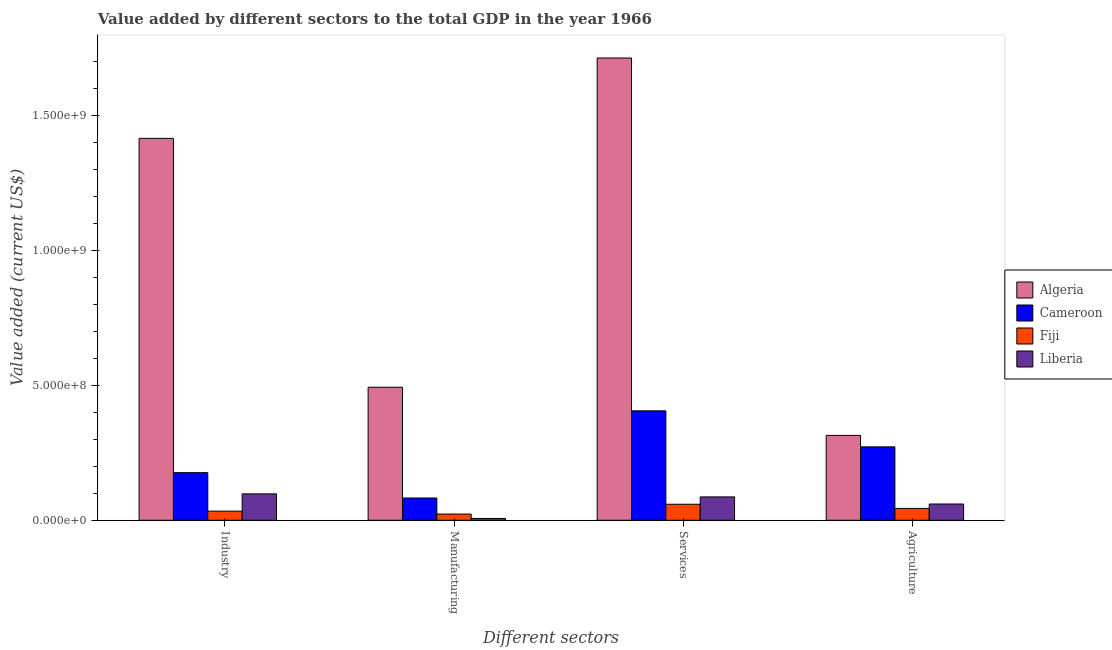How many different coloured bars are there?
Provide a succinct answer. 4. Are the number of bars on each tick of the X-axis equal?
Keep it short and to the point. Yes. How many bars are there on the 2nd tick from the left?
Your answer should be compact. 4. What is the label of the 3rd group of bars from the left?
Your answer should be very brief. Services. What is the value added by manufacturing sector in Fiji?
Give a very brief answer. 2.30e+07. Across all countries, what is the maximum value added by manufacturing sector?
Make the answer very short. 4.93e+08. Across all countries, what is the minimum value added by services sector?
Ensure brevity in your answer.  5.93e+07. In which country was the value added by agricultural sector maximum?
Offer a very short reply. Algeria. In which country was the value added by manufacturing sector minimum?
Ensure brevity in your answer.  Liberia. What is the total value added by manufacturing sector in the graph?
Your answer should be compact. 6.05e+08. What is the difference between the value added by industrial sector in Algeria and that in Fiji?
Make the answer very short. 1.38e+09. What is the difference between the value added by services sector in Fiji and the value added by industrial sector in Liberia?
Your answer should be very brief. -3.85e+07. What is the average value added by industrial sector per country?
Give a very brief answer. 4.30e+08. What is the difference between the value added by manufacturing sector and value added by agricultural sector in Fiji?
Give a very brief answer. -2.08e+07. In how many countries, is the value added by manufacturing sector greater than 400000000 US$?
Offer a very short reply. 1. What is the ratio of the value added by agricultural sector in Liberia to that in Fiji?
Your answer should be compact. 1.37. Is the value added by industrial sector in Algeria less than that in Fiji?
Ensure brevity in your answer.  No. What is the difference between the highest and the second highest value added by services sector?
Your answer should be compact. 1.31e+09. What is the difference between the highest and the lowest value added by manufacturing sector?
Provide a succinct answer. 4.86e+08. What does the 3rd bar from the left in Manufacturing represents?
Provide a succinct answer. Fiji. What does the 1st bar from the right in Industry represents?
Provide a succinct answer. Liberia. How many countries are there in the graph?
Provide a short and direct response. 4. What is the difference between two consecutive major ticks on the Y-axis?
Keep it short and to the point. 5.00e+08. Are the values on the major ticks of Y-axis written in scientific E-notation?
Ensure brevity in your answer.  Yes. Where does the legend appear in the graph?
Offer a very short reply. Center right. How many legend labels are there?
Offer a very short reply. 4. How are the legend labels stacked?
Provide a succinct answer. Vertical. What is the title of the graph?
Keep it short and to the point. Value added by different sectors to the total GDP in the year 1966. What is the label or title of the X-axis?
Offer a very short reply. Different sectors. What is the label or title of the Y-axis?
Make the answer very short. Value added (current US$). What is the Value added (current US$) of Algeria in Industry?
Your answer should be very brief. 1.41e+09. What is the Value added (current US$) of Cameroon in Industry?
Keep it short and to the point. 1.76e+08. What is the Value added (current US$) in Fiji in Industry?
Keep it short and to the point. 3.38e+07. What is the Value added (current US$) in Liberia in Industry?
Your response must be concise. 9.78e+07. What is the Value added (current US$) in Algeria in Manufacturing?
Ensure brevity in your answer.  4.93e+08. What is the Value added (current US$) in Cameroon in Manufacturing?
Offer a very short reply. 8.24e+07. What is the Value added (current US$) of Fiji in Manufacturing?
Your answer should be compact. 2.30e+07. What is the Value added (current US$) of Liberia in Manufacturing?
Your answer should be very brief. 6.66e+06. What is the Value added (current US$) in Algeria in Services?
Offer a terse response. 1.71e+09. What is the Value added (current US$) of Cameroon in Services?
Your response must be concise. 4.05e+08. What is the Value added (current US$) of Fiji in Services?
Give a very brief answer. 5.93e+07. What is the Value added (current US$) of Liberia in Services?
Provide a short and direct response. 8.65e+07. What is the Value added (current US$) of Algeria in Agriculture?
Give a very brief answer. 3.14e+08. What is the Value added (current US$) of Cameroon in Agriculture?
Ensure brevity in your answer.  2.72e+08. What is the Value added (current US$) of Fiji in Agriculture?
Keep it short and to the point. 4.38e+07. What is the Value added (current US$) in Liberia in Agriculture?
Provide a short and direct response. 6.02e+07. Across all Different sectors, what is the maximum Value added (current US$) of Algeria?
Offer a terse response. 1.71e+09. Across all Different sectors, what is the maximum Value added (current US$) in Cameroon?
Your answer should be very brief. 4.05e+08. Across all Different sectors, what is the maximum Value added (current US$) of Fiji?
Give a very brief answer. 5.93e+07. Across all Different sectors, what is the maximum Value added (current US$) of Liberia?
Ensure brevity in your answer.  9.78e+07. Across all Different sectors, what is the minimum Value added (current US$) in Algeria?
Your response must be concise. 3.14e+08. Across all Different sectors, what is the minimum Value added (current US$) in Cameroon?
Provide a short and direct response. 8.24e+07. Across all Different sectors, what is the minimum Value added (current US$) in Fiji?
Offer a very short reply. 2.30e+07. Across all Different sectors, what is the minimum Value added (current US$) in Liberia?
Your answer should be very brief. 6.66e+06. What is the total Value added (current US$) of Algeria in the graph?
Keep it short and to the point. 3.93e+09. What is the total Value added (current US$) in Cameroon in the graph?
Make the answer very short. 9.36e+08. What is the total Value added (current US$) of Fiji in the graph?
Give a very brief answer. 1.60e+08. What is the total Value added (current US$) in Liberia in the graph?
Keep it short and to the point. 2.51e+08. What is the difference between the Value added (current US$) in Algeria in Industry and that in Manufacturing?
Your answer should be compact. 9.21e+08. What is the difference between the Value added (current US$) in Cameroon in Industry and that in Manufacturing?
Your response must be concise. 9.39e+07. What is the difference between the Value added (current US$) in Fiji in Industry and that in Manufacturing?
Ensure brevity in your answer.  1.08e+07. What is the difference between the Value added (current US$) of Liberia in Industry and that in Manufacturing?
Your response must be concise. 9.11e+07. What is the difference between the Value added (current US$) in Algeria in Industry and that in Services?
Offer a very short reply. -2.98e+08. What is the difference between the Value added (current US$) in Cameroon in Industry and that in Services?
Offer a very short reply. -2.29e+08. What is the difference between the Value added (current US$) of Fiji in Industry and that in Services?
Provide a succinct answer. -2.54e+07. What is the difference between the Value added (current US$) in Liberia in Industry and that in Services?
Your answer should be very brief. 1.13e+07. What is the difference between the Value added (current US$) in Algeria in Industry and that in Agriculture?
Provide a short and direct response. 1.10e+09. What is the difference between the Value added (current US$) in Cameroon in Industry and that in Agriculture?
Your response must be concise. -9.55e+07. What is the difference between the Value added (current US$) in Fiji in Industry and that in Agriculture?
Offer a very short reply. -9.94e+06. What is the difference between the Value added (current US$) in Liberia in Industry and that in Agriculture?
Provide a succinct answer. 3.76e+07. What is the difference between the Value added (current US$) of Algeria in Manufacturing and that in Services?
Make the answer very short. -1.22e+09. What is the difference between the Value added (current US$) of Cameroon in Manufacturing and that in Services?
Ensure brevity in your answer.  -3.23e+08. What is the difference between the Value added (current US$) in Fiji in Manufacturing and that in Services?
Offer a terse response. -3.62e+07. What is the difference between the Value added (current US$) of Liberia in Manufacturing and that in Services?
Ensure brevity in your answer.  -7.98e+07. What is the difference between the Value added (current US$) of Algeria in Manufacturing and that in Agriculture?
Ensure brevity in your answer.  1.78e+08. What is the difference between the Value added (current US$) in Cameroon in Manufacturing and that in Agriculture?
Provide a succinct answer. -1.89e+08. What is the difference between the Value added (current US$) of Fiji in Manufacturing and that in Agriculture?
Make the answer very short. -2.08e+07. What is the difference between the Value added (current US$) of Liberia in Manufacturing and that in Agriculture?
Offer a terse response. -5.35e+07. What is the difference between the Value added (current US$) of Algeria in Services and that in Agriculture?
Your answer should be compact. 1.40e+09. What is the difference between the Value added (current US$) in Cameroon in Services and that in Agriculture?
Offer a very short reply. 1.33e+08. What is the difference between the Value added (current US$) in Fiji in Services and that in Agriculture?
Give a very brief answer. 1.55e+07. What is the difference between the Value added (current US$) of Liberia in Services and that in Agriculture?
Provide a short and direct response. 2.63e+07. What is the difference between the Value added (current US$) of Algeria in Industry and the Value added (current US$) of Cameroon in Manufacturing?
Your response must be concise. 1.33e+09. What is the difference between the Value added (current US$) of Algeria in Industry and the Value added (current US$) of Fiji in Manufacturing?
Your response must be concise. 1.39e+09. What is the difference between the Value added (current US$) in Algeria in Industry and the Value added (current US$) in Liberia in Manufacturing?
Your response must be concise. 1.41e+09. What is the difference between the Value added (current US$) of Cameroon in Industry and the Value added (current US$) of Fiji in Manufacturing?
Your response must be concise. 1.53e+08. What is the difference between the Value added (current US$) of Cameroon in Industry and the Value added (current US$) of Liberia in Manufacturing?
Make the answer very short. 1.70e+08. What is the difference between the Value added (current US$) of Fiji in Industry and the Value added (current US$) of Liberia in Manufacturing?
Your answer should be very brief. 2.72e+07. What is the difference between the Value added (current US$) in Algeria in Industry and the Value added (current US$) in Cameroon in Services?
Your answer should be compact. 1.01e+09. What is the difference between the Value added (current US$) of Algeria in Industry and the Value added (current US$) of Fiji in Services?
Your answer should be compact. 1.35e+09. What is the difference between the Value added (current US$) in Algeria in Industry and the Value added (current US$) in Liberia in Services?
Offer a very short reply. 1.33e+09. What is the difference between the Value added (current US$) in Cameroon in Industry and the Value added (current US$) in Fiji in Services?
Ensure brevity in your answer.  1.17e+08. What is the difference between the Value added (current US$) in Cameroon in Industry and the Value added (current US$) in Liberia in Services?
Ensure brevity in your answer.  8.98e+07. What is the difference between the Value added (current US$) of Fiji in Industry and the Value added (current US$) of Liberia in Services?
Your answer should be very brief. -5.27e+07. What is the difference between the Value added (current US$) in Algeria in Industry and the Value added (current US$) in Cameroon in Agriculture?
Your answer should be compact. 1.14e+09. What is the difference between the Value added (current US$) in Algeria in Industry and the Value added (current US$) in Fiji in Agriculture?
Keep it short and to the point. 1.37e+09. What is the difference between the Value added (current US$) of Algeria in Industry and the Value added (current US$) of Liberia in Agriculture?
Offer a terse response. 1.35e+09. What is the difference between the Value added (current US$) in Cameroon in Industry and the Value added (current US$) in Fiji in Agriculture?
Your response must be concise. 1.33e+08. What is the difference between the Value added (current US$) of Cameroon in Industry and the Value added (current US$) of Liberia in Agriculture?
Your response must be concise. 1.16e+08. What is the difference between the Value added (current US$) of Fiji in Industry and the Value added (current US$) of Liberia in Agriculture?
Provide a short and direct response. -2.64e+07. What is the difference between the Value added (current US$) of Algeria in Manufacturing and the Value added (current US$) of Cameroon in Services?
Offer a very short reply. 8.74e+07. What is the difference between the Value added (current US$) in Algeria in Manufacturing and the Value added (current US$) in Fiji in Services?
Give a very brief answer. 4.33e+08. What is the difference between the Value added (current US$) in Algeria in Manufacturing and the Value added (current US$) in Liberia in Services?
Ensure brevity in your answer.  4.06e+08. What is the difference between the Value added (current US$) of Cameroon in Manufacturing and the Value added (current US$) of Fiji in Services?
Your response must be concise. 2.32e+07. What is the difference between the Value added (current US$) of Cameroon in Manufacturing and the Value added (current US$) of Liberia in Services?
Keep it short and to the point. -4.07e+06. What is the difference between the Value added (current US$) in Fiji in Manufacturing and the Value added (current US$) in Liberia in Services?
Your answer should be compact. -6.35e+07. What is the difference between the Value added (current US$) of Algeria in Manufacturing and the Value added (current US$) of Cameroon in Agriculture?
Provide a short and direct response. 2.21e+08. What is the difference between the Value added (current US$) in Algeria in Manufacturing and the Value added (current US$) in Fiji in Agriculture?
Your response must be concise. 4.49e+08. What is the difference between the Value added (current US$) of Algeria in Manufacturing and the Value added (current US$) of Liberia in Agriculture?
Offer a very short reply. 4.32e+08. What is the difference between the Value added (current US$) in Cameroon in Manufacturing and the Value added (current US$) in Fiji in Agriculture?
Offer a terse response. 3.86e+07. What is the difference between the Value added (current US$) of Cameroon in Manufacturing and the Value added (current US$) of Liberia in Agriculture?
Your answer should be very brief. 2.22e+07. What is the difference between the Value added (current US$) of Fiji in Manufacturing and the Value added (current US$) of Liberia in Agriculture?
Make the answer very short. -3.72e+07. What is the difference between the Value added (current US$) in Algeria in Services and the Value added (current US$) in Cameroon in Agriculture?
Provide a short and direct response. 1.44e+09. What is the difference between the Value added (current US$) in Algeria in Services and the Value added (current US$) in Fiji in Agriculture?
Your answer should be very brief. 1.67e+09. What is the difference between the Value added (current US$) in Algeria in Services and the Value added (current US$) in Liberia in Agriculture?
Keep it short and to the point. 1.65e+09. What is the difference between the Value added (current US$) of Cameroon in Services and the Value added (current US$) of Fiji in Agriculture?
Your answer should be very brief. 3.61e+08. What is the difference between the Value added (current US$) in Cameroon in Services and the Value added (current US$) in Liberia in Agriculture?
Your response must be concise. 3.45e+08. What is the difference between the Value added (current US$) of Fiji in Services and the Value added (current US$) of Liberia in Agriculture?
Keep it short and to the point. -9.37e+05. What is the average Value added (current US$) in Algeria per Different sectors?
Ensure brevity in your answer.  9.83e+08. What is the average Value added (current US$) of Cameroon per Different sectors?
Make the answer very short. 2.34e+08. What is the average Value added (current US$) of Fiji per Different sectors?
Provide a short and direct response. 4.00e+07. What is the average Value added (current US$) in Liberia per Different sectors?
Offer a very short reply. 6.28e+07. What is the difference between the Value added (current US$) in Algeria and Value added (current US$) in Cameroon in Industry?
Ensure brevity in your answer.  1.24e+09. What is the difference between the Value added (current US$) in Algeria and Value added (current US$) in Fiji in Industry?
Give a very brief answer. 1.38e+09. What is the difference between the Value added (current US$) of Algeria and Value added (current US$) of Liberia in Industry?
Provide a short and direct response. 1.32e+09. What is the difference between the Value added (current US$) of Cameroon and Value added (current US$) of Fiji in Industry?
Offer a very short reply. 1.42e+08. What is the difference between the Value added (current US$) of Cameroon and Value added (current US$) of Liberia in Industry?
Your response must be concise. 7.85e+07. What is the difference between the Value added (current US$) of Fiji and Value added (current US$) of Liberia in Industry?
Offer a terse response. -6.39e+07. What is the difference between the Value added (current US$) in Algeria and Value added (current US$) in Cameroon in Manufacturing?
Your answer should be compact. 4.10e+08. What is the difference between the Value added (current US$) in Algeria and Value added (current US$) in Fiji in Manufacturing?
Provide a succinct answer. 4.70e+08. What is the difference between the Value added (current US$) of Algeria and Value added (current US$) of Liberia in Manufacturing?
Give a very brief answer. 4.86e+08. What is the difference between the Value added (current US$) of Cameroon and Value added (current US$) of Fiji in Manufacturing?
Keep it short and to the point. 5.94e+07. What is the difference between the Value added (current US$) in Cameroon and Value added (current US$) in Liberia in Manufacturing?
Offer a terse response. 7.58e+07. What is the difference between the Value added (current US$) of Fiji and Value added (current US$) of Liberia in Manufacturing?
Keep it short and to the point. 1.64e+07. What is the difference between the Value added (current US$) in Algeria and Value added (current US$) in Cameroon in Services?
Your answer should be very brief. 1.31e+09. What is the difference between the Value added (current US$) of Algeria and Value added (current US$) of Fiji in Services?
Your answer should be very brief. 1.65e+09. What is the difference between the Value added (current US$) in Algeria and Value added (current US$) in Liberia in Services?
Your answer should be compact. 1.63e+09. What is the difference between the Value added (current US$) in Cameroon and Value added (current US$) in Fiji in Services?
Provide a short and direct response. 3.46e+08. What is the difference between the Value added (current US$) in Cameroon and Value added (current US$) in Liberia in Services?
Your answer should be compact. 3.19e+08. What is the difference between the Value added (current US$) of Fiji and Value added (current US$) of Liberia in Services?
Ensure brevity in your answer.  -2.72e+07. What is the difference between the Value added (current US$) of Algeria and Value added (current US$) of Cameroon in Agriculture?
Make the answer very short. 4.26e+07. What is the difference between the Value added (current US$) of Algeria and Value added (current US$) of Fiji in Agriculture?
Offer a terse response. 2.71e+08. What is the difference between the Value added (current US$) of Algeria and Value added (current US$) of Liberia in Agriculture?
Your answer should be compact. 2.54e+08. What is the difference between the Value added (current US$) in Cameroon and Value added (current US$) in Fiji in Agriculture?
Offer a very short reply. 2.28e+08. What is the difference between the Value added (current US$) of Cameroon and Value added (current US$) of Liberia in Agriculture?
Your response must be concise. 2.12e+08. What is the difference between the Value added (current US$) in Fiji and Value added (current US$) in Liberia in Agriculture?
Give a very brief answer. -1.64e+07. What is the ratio of the Value added (current US$) of Algeria in Industry to that in Manufacturing?
Offer a very short reply. 2.87. What is the ratio of the Value added (current US$) of Cameroon in Industry to that in Manufacturing?
Keep it short and to the point. 2.14. What is the ratio of the Value added (current US$) in Fiji in Industry to that in Manufacturing?
Your response must be concise. 1.47. What is the ratio of the Value added (current US$) of Liberia in Industry to that in Manufacturing?
Your answer should be compact. 14.68. What is the ratio of the Value added (current US$) of Algeria in Industry to that in Services?
Offer a very short reply. 0.83. What is the ratio of the Value added (current US$) in Cameroon in Industry to that in Services?
Offer a very short reply. 0.43. What is the ratio of the Value added (current US$) of Fiji in Industry to that in Services?
Keep it short and to the point. 0.57. What is the ratio of the Value added (current US$) of Liberia in Industry to that in Services?
Give a very brief answer. 1.13. What is the ratio of the Value added (current US$) in Algeria in Industry to that in Agriculture?
Offer a terse response. 4.5. What is the ratio of the Value added (current US$) in Cameroon in Industry to that in Agriculture?
Your response must be concise. 0.65. What is the ratio of the Value added (current US$) in Fiji in Industry to that in Agriculture?
Offer a very short reply. 0.77. What is the ratio of the Value added (current US$) in Liberia in Industry to that in Agriculture?
Make the answer very short. 1.62. What is the ratio of the Value added (current US$) in Algeria in Manufacturing to that in Services?
Provide a succinct answer. 0.29. What is the ratio of the Value added (current US$) in Cameroon in Manufacturing to that in Services?
Offer a terse response. 0.2. What is the ratio of the Value added (current US$) in Fiji in Manufacturing to that in Services?
Your answer should be very brief. 0.39. What is the ratio of the Value added (current US$) in Liberia in Manufacturing to that in Services?
Your answer should be very brief. 0.08. What is the ratio of the Value added (current US$) of Algeria in Manufacturing to that in Agriculture?
Ensure brevity in your answer.  1.57. What is the ratio of the Value added (current US$) in Cameroon in Manufacturing to that in Agriculture?
Your response must be concise. 0.3. What is the ratio of the Value added (current US$) in Fiji in Manufacturing to that in Agriculture?
Provide a short and direct response. 0.53. What is the ratio of the Value added (current US$) of Liberia in Manufacturing to that in Agriculture?
Provide a short and direct response. 0.11. What is the ratio of the Value added (current US$) of Algeria in Services to that in Agriculture?
Provide a succinct answer. 5.45. What is the ratio of the Value added (current US$) of Cameroon in Services to that in Agriculture?
Keep it short and to the point. 1.49. What is the ratio of the Value added (current US$) in Fiji in Services to that in Agriculture?
Make the answer very short. 1.35. What is the ratio of the Value added (current US$) of Liberia in Services to that in Agriculture?
Your answer should be very brief. 1.44. What is the difference between the highest and the second highest Value added (current US$) in Algeria?
Make the answer very short. 2.98e+08. What is the difference between the highest and the second highest Value added (current US$) in Cameroon?
Your answer should be compact. 1.33e+08. What is the difference between the highest and the second highest Value added (current US$) in Fiji?
Your answer should be compact. 1.55e+07. What is the difference between the highest and the second highest Value added (current US$) of Liberia?
Your response must be concise. 1.13e+07. What is the difference between the highest and the lowest Value added (current US$) of Algeria?
Your response must be concise. 1.40e+09. What is the difference between the highest and the lowest Value added (current US$) of Cameroon?
Your answer should be very brief. 3.23e+08. What is the difference between the highest and the lowest Value added (current US$) in Fiji?
Provide a short and direct response. 3.62e+07. What is the difference between the highest and the lowest Value added (current US$) in Liberia?
Provide a short and direct response. 9.11e+07. 